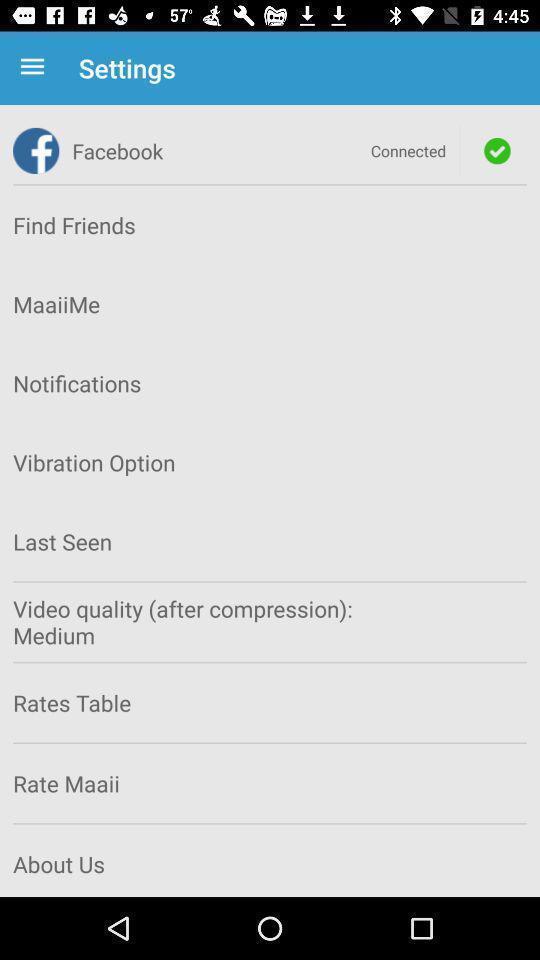Give me a summary of this screen capture. Settings in the social media application. 